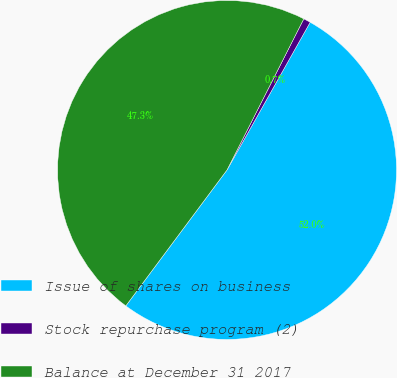Convert chart to OTSL. <chart><loc_0><loc_0><loc_500><loc_500><pie_chart><fcel>Issue of shares on business<fcel>Stock repurchase program (2)<fcel>Balance at December 31 2017<nl><fcel>52.03%<fcel>0.68%<fcel>47.3%<nl></chart> 